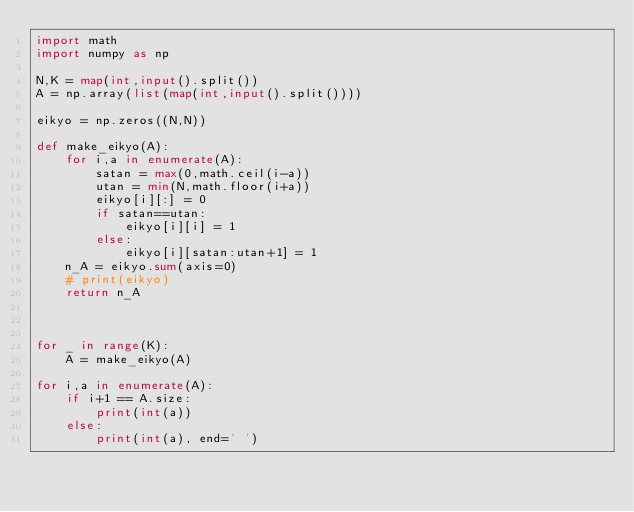Convert code to text. <code><loc_0><loc_0><loc_500><loc_500><_Python_>import math
import numpy as np

N,K = map(int,input().split())
A = np.array(list(map(int,input().split())))

eikyo = np.zeros((N,N))

def make_eikyo(A):
    for i,a in enumerate(A):
        satan = max(0,math.ceil(i-a))
        utan = min(N,math.floor(i+a))
        eikyo[i][:] = 0
        if satan==utan:
            eikyo[i][i] = 1
        else:
            eikyo[i][satan:utan+1] = 1
    n_A = eikyo.sum(axis=0)
    # print(eikyo)
    return n_A



for _ in range(K):
    A = make_eikyo(A)

for i,a in enumerate(A):
    if i+1 == A.size:
        print(int(a))
    else:
        print(int(a), end=' ')
</code> 